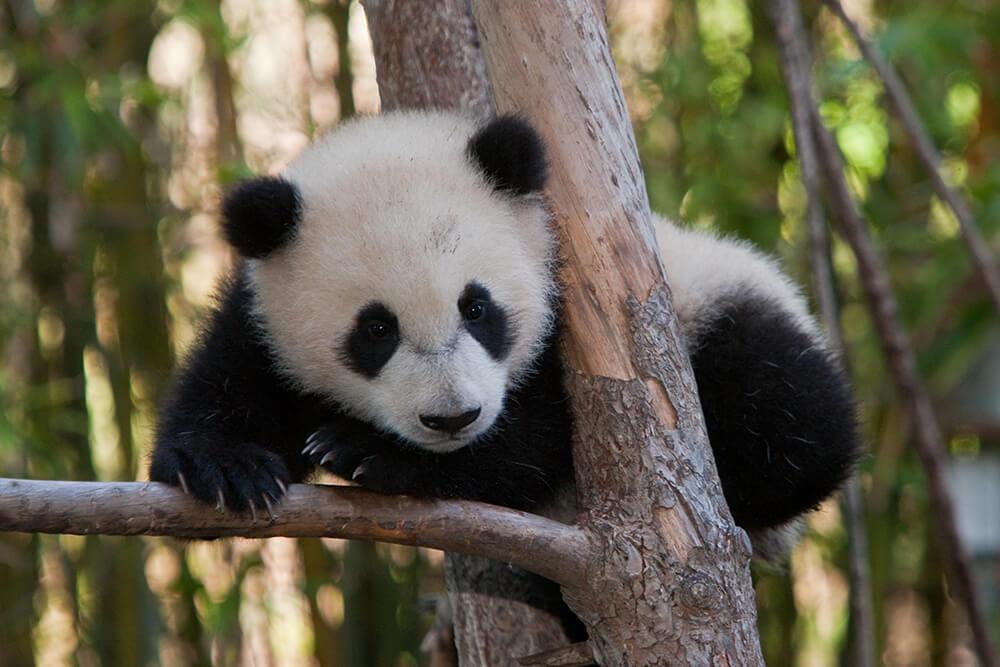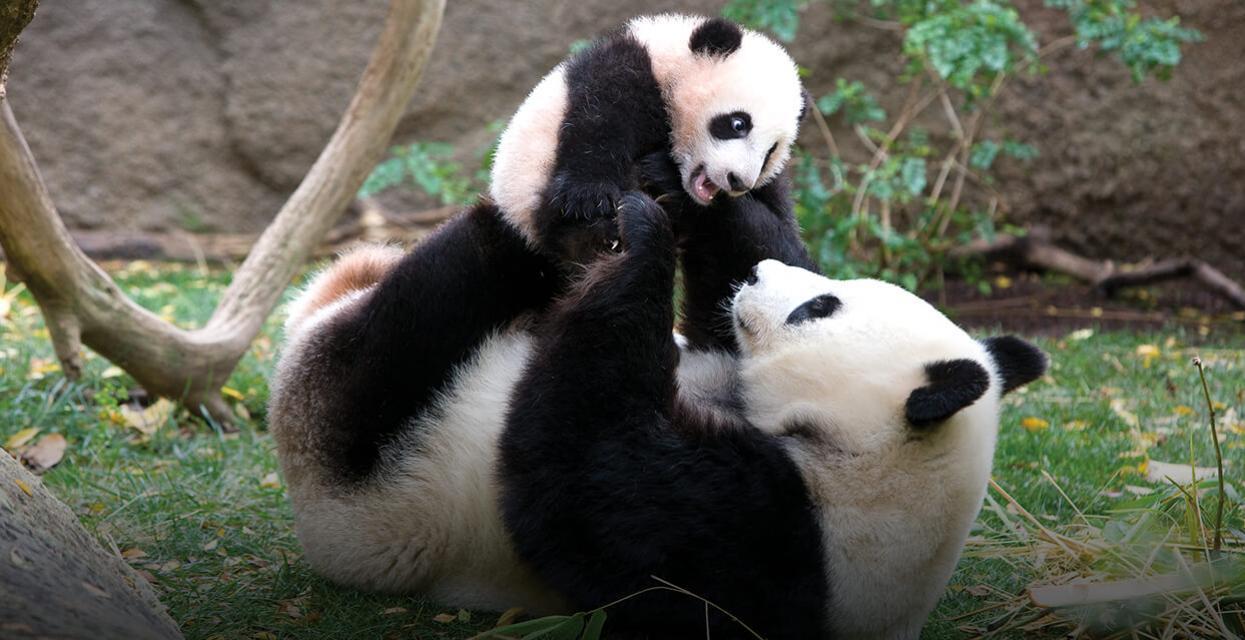The first image is the image on the left, the second image is the image on the right. Examine the images to the left and right. Is the description "a single panda is eating bamboo in the pair of images" accurate? Answer yes or no. No. The first image is the image on the left, the second image is the image on the right. Evaluate the accuracy of this statement regarding the images: "There is a lone panda bear sitting down while eating some bamboo.". Is it true? Answer yes or no. No. 